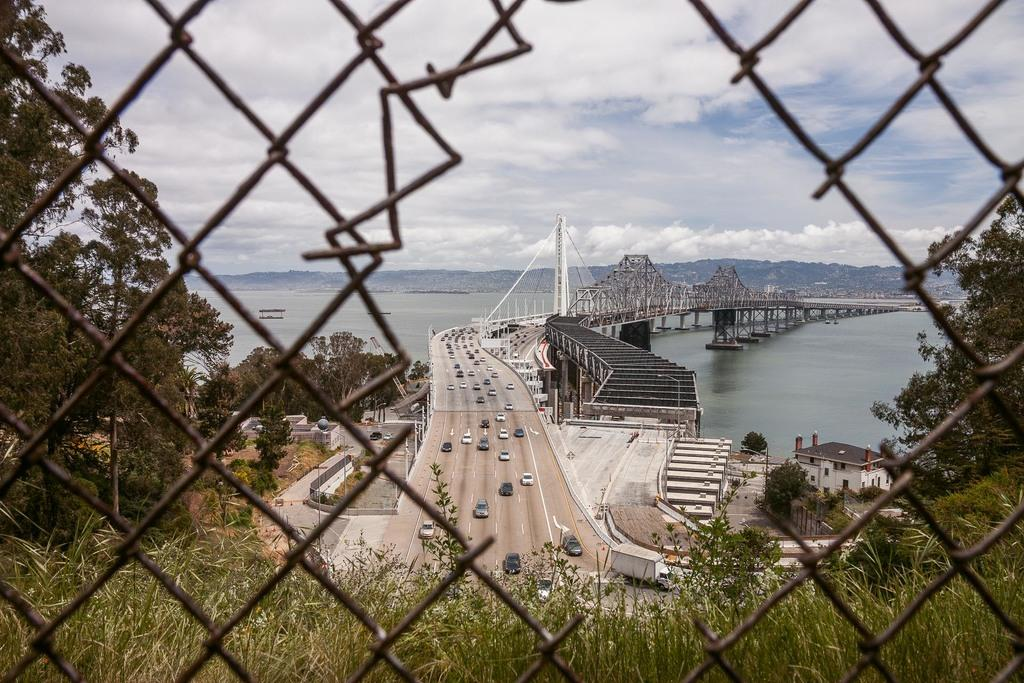What type of barrier can be seen in the image? There is a fence in the image. What type of vegetation is present in the image? There are plants and trees in the image. What can be seen on the road in the image? Vehicles are visible on the road in the image. What type of structure is present in the image? There is a bridge in the image. What natural feature is present in the image? Water is present in the image. What is visible in the background of the image? There are mountains and the sky in the background of the image. What time does the clock show in the image? There is no clock present in the image. What type of animal is biting the fence in the image? There are no animals biting the fence in the image. 